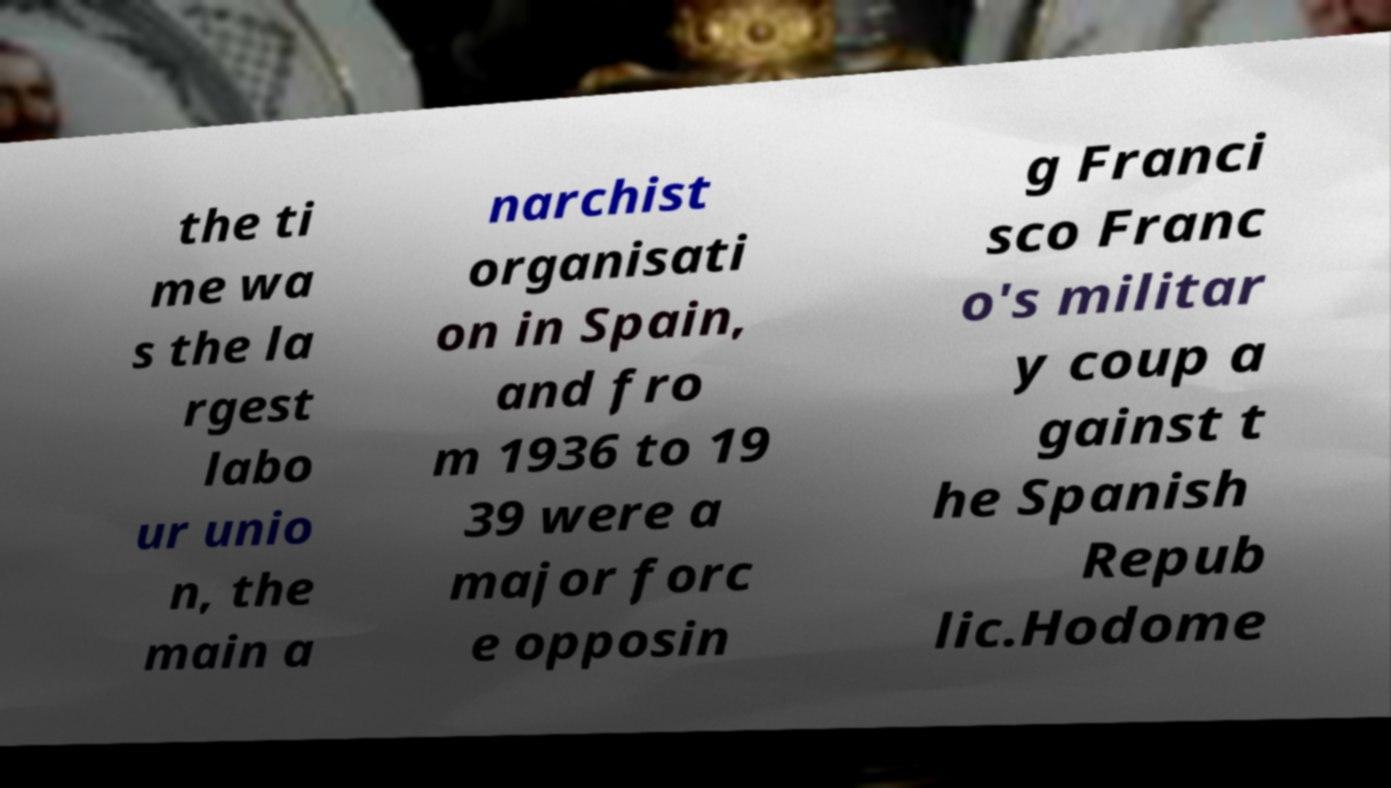Please read and relay the text visible in this image. What does it say? the ti me wa s the la rgest labo ur unio n, the main a narchist organisati on in Spain, and fro m 1936 to 19 39 were a major forc e opposin g Franci sco Franc o's militar y coup a gainst t he Spanish Repub lic.Hodome 